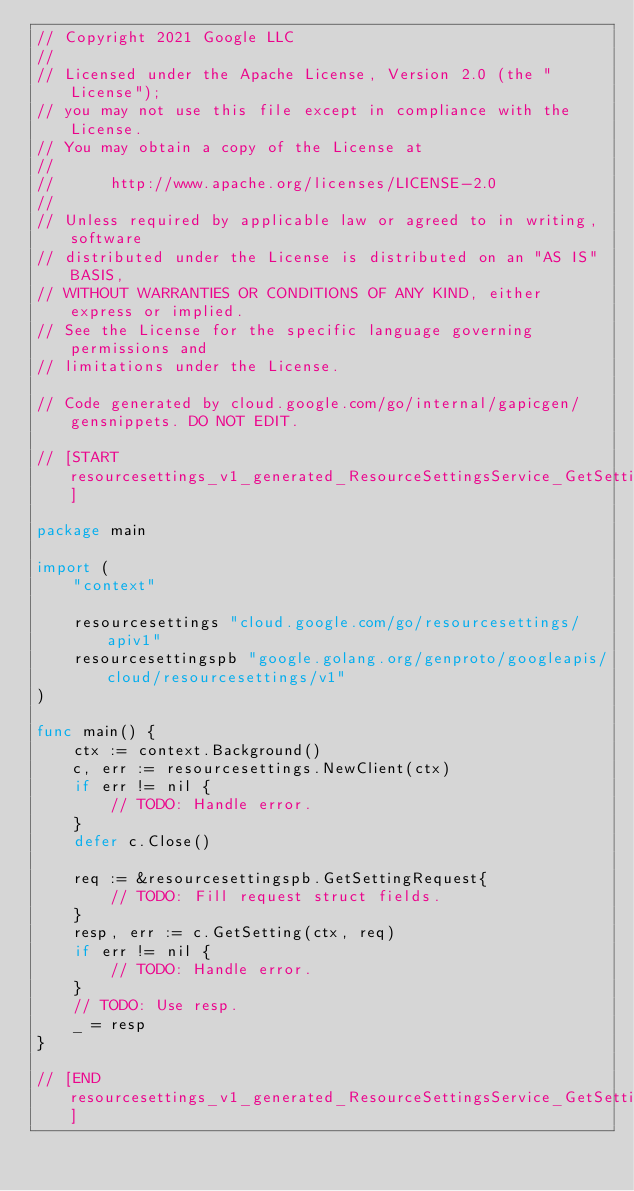<code> <loc_0><loc_0><loc_500><loc_500><_Go_>// Copyright 2021 Google LLC
//
// Licensed under the Apache License, Version 2.0 (the "License");
// you may not use this file except in compliance with the License.
// You may obtain a copy of the License at
//
//      http://www.apache.org/licenses/LICENSE-2.0
//
// Unless required by applicable law or agreed to in writing, software
// distributed under the License is distributed on an "AS IS" BASIS,
// WITHOUT WARRANTIES OR CONDITIONS OF ANY KIND, either express or implied.
// See the License for the specific language governing permissions and
// limitations under the License.

// Code generated by cloud.google.com/go/internal/gapicgen/gensnippets. DO NOT EDIT.

// [START resourcesettings_v1_generated_ResourceSettingsService_GetSetting_sync]

package main

import (
	"context"

	resourcesettings "cloud.google.com/go/resourcesettings/apiv1"
	resourcesettingspb "google.golang.org/genproto/googleapis/cloud/resourcesettings/v1"
)

func main() {
	ctx := context.Background()
	c, err := resourcesettings.NewClient(ctx)
	if err != nil {
		// TODO: Handle error.
	}
	defer c.Close()

	req := &resourcesettingspb.GetSettingRequest{
		// TODO: Fill request struct fields.
	}
	resp, err := c.GetSetting(ctx, req)
	if err != nil {
		// TODO: Handle error.
	}
	// TODO: Use resp.
	_ = resp
}

// [END resourcesettings_v1_generated_ResourceSettingsService_GetSetting_sync]
</code> 